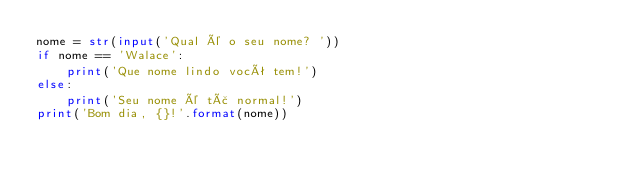<code> <loc_0><loc_0><loc_500><loc_500><_Python_>nome = str(input('Qual é o seu nome? '))
if nome == 'Walace':
    print('Que nome lindo você tem!')
else:
    print('Seu nome é tã normal!')
print('Bom dia, {}!'.format(nome))
</code> 